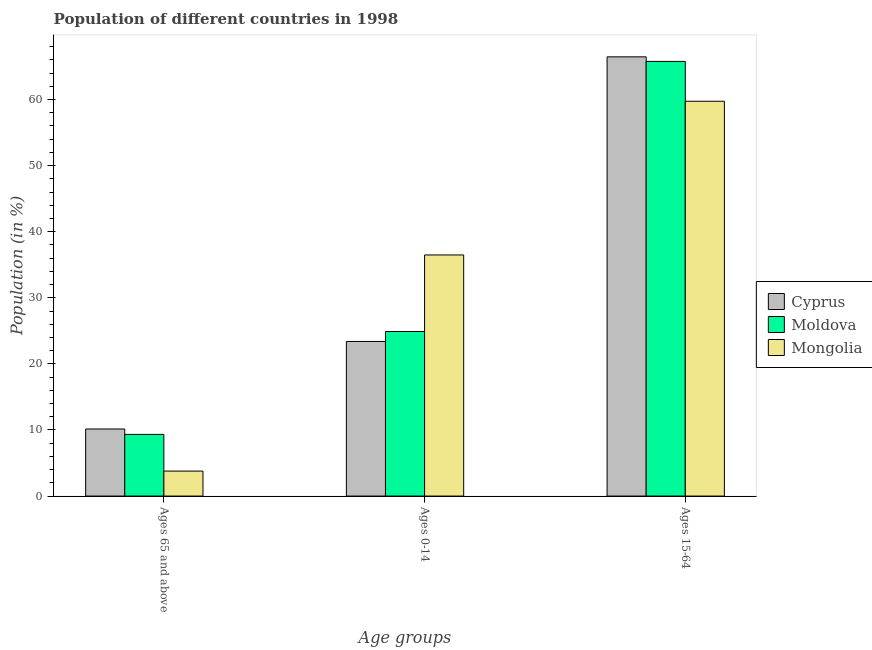How many different coloured bars are there?
Provide a succinct answer. 3. Are the number of bars on each tick of the X-axis equal?
Offer a terse response. Yes. How many bars are there on the 2nd tick from the left?
Your answer should be very brief. 3. How many bars are there on the 1st tick from the right?
Keep it short and to the point. 3. What is the label of the 2nd group of bars from the left?
Offer a terse response. Ages 0-14. What is the percentage of population within the age-group 0-14 in Mongolia?
Offer a very short reply. 36.48. Across all countries, what is the maximum percentage of population within the age-group 0-14?
Give a very brief answer. 36.48. Across all countries, what is the minimum percentage of population within the age-group 15-64?
Give a very brief answer. 59.74. In which country was the percentage of population within the age-group 15-64 maximum?
Ensure brevity in your answer.  Cyprus. In which country was the percentage of population within the age-group of 65 and above minimum?
Offer a terse response. Mongolia. What is the total percentage of population within the age-group of 65 and above in the graph?
Provide a short and direct response. 23.26. What is the difference between the percentage of population within the age-group of 65 and above in Moldova and that in Mongolia?
Provide a short and direct response. 5.55. What is the difference between the percentage of population within the age-group of 65 and above in Mongolia and the percentage of population within the age-group 0-14 in Moldova?
Your answer should be very brief. -21.12. What is the average percentage of population within the age-group 0-14 per country?
Provide a short and direct response. 28.26. What is the difference between the percentage of population within the age-group 15-64 and percentage of population within the age-group of 65 and above in Mongolia?
Make the answer very short. 55.96. In how many countries, is the percentage of population within the age-group 0-14 greater than 8 %?
Keep it short and to the point. 3. What is the ratio of the percentage of population within the age-group 15-64 in Mongolia to that in Moldova?
Provide a succinct answer. 0.91. Is the percentage of population within the age-group of 65 and above in Mongolia less than that in Moldova?
Keep it short and to the point. Yes. What is the difference between the highest and the second highest percentage of population within the age-group 0-14?
Your response must be concise. 11.58. What is the difference between the highest and the lowest percentage of population within the age-group of 65 and above?
Keep it short and to the point. 6.37. What does the 2nd bar from the left in Ages 65 and above represents?
Make the answer very short. Moldova. What does the 1st bar from the right in Ages 0-14 represents?
Make the answer very short. Mongolia. Is it the case that in every country, the sum of the percentage of population within the age-group of 65 and above and percentage of population within the age-group 0-14 is greater than the percentage of population within the age-group 15-64?
Your response must be concise. No. How many bars are there?
Make the answer very short. 9. Are all the bars in the graph horizontal?
Your response must be concise. No. How many countries are there in the graph?
Your response must be concise. 3. Are the values on the major ticks of Y-axis written in scientific E-notation?
Give a very brief answer. No. Where does the legend appear in the graph?
Keep it short and to the point. Center right. How many legend labels are there?
Offer a very short reply. 3. How are the legend labels stacked?
Offer a very short reply. Vertical. What is the title of the graph?
Provide a short and direct response. Population of different countries in 1998. What is the label or title of the X-axis?
Offer a very short reply. Age groups. What is the label or title of the Y-axis?
Your response must be concise. Population (in %). What is the Population (in %) of Cyprus in Ages 65 and above?
Offer a very short reply. 10.15. What is the Population (in %) of Moldova in Ages 65 and above?
Offer a very short reply. 9.33. What is the Population (in %) in Mongolia in Ages 65 and above?
Offer a terse response. 3.78. What is the Population (in %) in Cyprus in Ages 0-14?
Give a very brief answer. 23.39. What is the Population (in %) in Moldova in Ages 0-14?
Provide a succinct answer. 24.9. What is the Population (in %) of Mongolia in Ages 0-14?
Offer a terse response. 36.48. What is the Population (in %) in Cyprus in Ages 15-64?
Offer a terse response. 66.46. What is the Population (in %) of Moldova in Ages 15-64?
Ensure brevity in your answer.  65.77. What is the Population (in %) of Mongolia in Ages 15-64?
Keep it short and to the point. 59.74. Across all Age groups, what is the maximum Population (in %) in Cyprus?
Keep it short and to the point. 66.46. Across all Age groups, what is the maximum Population (in %) in Moldova?
Your answer should be compact. 65.77. Across all Age groups, what is the maximum Population (in %) of Mongolia?
Your response must be concise. 59.74. Across all Age groups, what is the minimum Population (in %) in Cyprus?
Ensure brevity in your answer.  10.15. Across all Age groups, what is the minimum Population (in %) in Moldova?
Your response must be concise. 9.33. Across all Age groups, what is the minimum Population (in %) of Mongolia?
Ensure brevity in your answer.  3.78. What is the total Population (in %) in Cyprus in the graph?
Ensure brevity in your answer.  100. What is the total Population (in %) in Moldova in the graph?
Your answer should be very brief. 100. What is the total Population (in %) in Mongolia in the graph?
Make the answer very short. 100. What is the difference between the Population (in %) of Cyprus in Ages 65 and above and that in Ages 0-14?
Provide a succinct answer. -13.25. What is the difference between the Population (in %) in Moldova in Ages 65 and above and that in Ages 0-14?
Keep it short and to the point. -15.57. What is the difference between the Population (in %) in Mongolia in Ages 65 and above and that in Ages 0-14?
Give a very brief answer. -32.7. What is the difference between the Population (in %) in Cyprus in Ages 65 and above and that in Ages 15-64?
Offer a very short reply. -56.31. What is the difference between the Population (in %) of Moldova in Ages 65 and above and that in Ages 15-64?
Provide a short and direct response. -56.43. What is the difference between the Population (in %) of Mongolia in Ages 65 and above and that in Ages 15-64?
Provide a succinct answer. -55.96. What is the difference between the Population (in %) of Cyprus in Ages 0-14 and that in Ages 15-64?
Your answer should be very brief. -43.07. What is the difference between the Population (in %) of Moldova in Ages 0-14 and that in Ages 15-64?
Offer a very short reply. -40.86. What is the difference between the Population (in %) of Mongolia in Ages 0-14 and that in Ages 15-64?
Ensure brevity in your answer.  -23.26. What is the difference between the Population (in %) in Cyprus in Ages 65 and above and the Population (in %) in Moldova in Ages 0-14?
Provide a short and direct response. -14.75. What is the difference between the Population (in %) of Cyprus in Ages 65 and above and the Population (in %) of Mongolia in Ages 0-14?
Give a very brief answer. -26.33. What is the difference between the Population (in %) in Moldova in Ages 65 and above and the Population (in %) in Mongolia in Ages 0-14?
Your response must be concise. -27.15. What is the difference between the Population (in %) in Cyprus in Ages 65 and above and the Population (in %) in Moldova in Ages 15-64?
Your answer should be compact. -55.62. What is the difference between the Population (in %) of Cyprus in Ages 65 and above and the Population (in %) of Mongolia in Ages 15-64?
Your answer should be compact. -49.59. What is the difference between the Population (in %) in Moldova in Ages 65 and above and the Population (in %) in Mongolia in Ages 15-64?
Make the answer very short. -50.41. What is the difference between the Population (in %) of Cyprus in Ages 0-14 and the Population (in %) of Moldova in Ages 15-64?
Make the answer very short. -42.37. What is the difference between the Population (in %) in Cyprus in Ages 0-14 and the Population (in %) in Mongolia in Ages 15-64?
Your response must be concise. -36.35. What is the difference between the Population (in %) in Moldova in Ages 0-14 and the Population (in %) in Mongolia in Ages 15-64?
Keep it short and to the point. -34.84. What is the average Population (in %) in Cyprus per Age groups?
Your response must be concise. 33.33. What is the average Population (in %) of Moldova per Age groups?
Provide a short and direct response. 33.33. What is the average Population (in %) in Mongolia per Age groups?
Your response must be concise. 33.33. What is the difference between the Population (in %) in Cyprus and Population (in %) in Moldova in Ages 65 and above?
Make the answer very short. 0.82. What is the difference between the Population (in %) in Cyprus and Population (in %) in Mongolia in Ages 65 and above?
Make the answer very short. 6.37. What is the difference between the Population (in %) in Moldova and Population (in %) in Mongolia in Ages 65 and above?
Provide a succinct answer. 5.55. What is the difference between the Population (in %) of Cyprus and Population (in %) of Moldova in Ages 0-14?
Make the answer very short. -1.51. What is the difference between the Population (in %) of Cyprus and Population (in %) of Mongolia in Ages 0-14?
Make the answer very short. -13.09. What is the difference between the Population (in %) of Moldova and Population (in %) of Mongolia in Ages 0-14?
Make the answer very short. -11.58. What is the difference between the Population (in %) of Cyprus and Population (in %) of Moldova in Ages 15-64?
Give a very brief answer. 0.69. What is the difference between the Population (in %) of Cyprus and Population (in %) of Mongolia in Ages 15-64?
Your response must be concise. 6.72. What is the difference between the Population (in %) of Moldova and Population (in %) of Mongolia in Ages 15-64?
Provide a short and direct response. 6.03. What is the ratio of the Population (in %) of Cyprus in Ages 65 and above to that in Ages 0-14?
Your response must be concise. 0.43. What is the ratio of the Population (in %) in Moldova in Ages 65 and above to that in Ages 0-14?
Ensure brevity in your answer.  0.37. What is the ratio of the Population (in %) of Mongolia in Ages 65 and above to that in Ages 0-14?
Make the answer very short. 0.1. What is the ratio of the Population (in %) of Cyprus in Ages 65 and above to that in Ages 15-64?
Offer a very short reply. 0.15. What is the ratio of the Population (in %) of Moldova in Ages 65 and above to that in Ages 15-64?
Offer a terse response. 0.14. What is the ratio of the Population (in %) in Mongolia in Ages 65 and above to that in Ages 15-64?
Offer a terse response. 0.06. What is the ratio of the Population (in %) of Cyprus in Ages 0-14 to that in Ages 15-64?
Keep it short and to the point. 0.35. What is the ratio of the Population (in %) in Moldova in Ages 0-14 to that in Ages 15-64?
Offer a terse response. 0.38. What is the ratio of the Population (in %) in Mongolia in Ages 0-14 to that in Ages 15-64?
Your answer should be compact. 0.61. What is the difference between the highest and the second highest Population (in %) of Cyprus?
Give a very brief answer. 43.07. What is the difference between the highest and the second highest Population (in %) of Moldova?
Ensure brevity in your answer.  40.86. What is the difference between the highest and the second highest Population (in %) of Mongolia?
Offer a very short reply. 23.26. What is the difference between the highest and the lowest Population (in %) in Cyprus?
Ensure brevity in your answer.  56.31. What is the difference between the highest and the lowest Population (in %) in Moldova?
Your answer should be compact. 56.43. What is the difference between the highest and the lowest Population (in %) of Mongolia?
Make the answer very short. 55.96. 